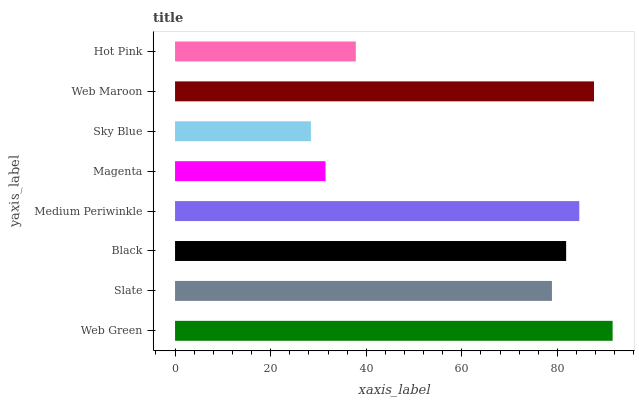Is Sky Blue the minimum?
Answer yes or no. Yes. Is Web Green the maximum?
Answer yes or no. Yes. Is Slate the minimum?
Answer yes or no. No. Is Slate the maximum?
Answer yes or no. No. Is Web Green greater than Slate?
Answer yes or no. Yes. Is Slate less than Web Green?
Answer yes or no. Yes. Is Slate greater than Web Green?
Answer yes or no. No. Is Web Green less than Slate?
Answer yes or no. No. Is Black the high median?
Answer yes or no. Yes. Is Slate the low median?
Answer yes or no. Yes. Is Medium Periwinkle the high median?
Answer yes or no. No. Is Sky Blue the low median?
Answer yes or no. No. 